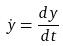<formula> <loc_0><loc_0><loc_500><loc_500>\dot { y } = \frac { d y } { d t }</formula> 